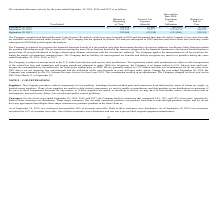From Clearfield's financial document, What is the balance at the beginning of 2019 and 2018 respectively? The document shows two values: $104,858 and 159,154. From the document: "September 30, 2018 159,154 79,377 (133,673) 104,858 September 30, 2019 $ 104,858 $ 10,448 $ (68,292) $ 47,014..." Also, What is the balance at the beginning of 2018 and 2017 respectively? The document shows two values: 159,154 and 322,404. From the document: "September 30, 2017 322,404 (32,154) (131,096) 159,154 September 30, 2017 322,404 (32,154) (131,096) 159,154..." Also, What is the income tax expense of fiscal years 2019 and 2018 respectively? The document shows two values: $10,448 and 79,377. From the document: "September 30, 2018 159,154 79,377 (133,673) 104,858 September 30, 2019 $ 104,858 $ 10,448 $ (68,292) $ 47,014..." Also, can you calculate: What is the percentage change in the end-of-year valuation allowance from 2018 to 2019? To answer this question, I need to perform calculations using the financial data. The calculation is: (47,014-104,858)/104,858, which equals -55.16 (percentage). This is based on the information: "eptember 30, 2019 $ 104,858 $ 10,448 $ (68,292) $ 47,014 September 30, 2019 $ 104,858 $ 10,448 $ (68,292) $ 47,014..." The key data points involved are: 104,858, 47,014. Also, can you calculate: What is the percentage change in the end-of-year valuation allowance from 2017 to 2018? To answer this question, I need to perform calculations using the financial data. The calculation is: (104,858-159,154)/159,154, which equals -34.12 (percentage). This is based on the information: "September 30, 2018 159,154 79,377 (133,673) 104,858 September 30, 2018 159,154 79,377 (133,673) 104,858..." The key data points involved are: 104,858, 159,154. Also, can you calculate: What is the percentage change in the income tax expense from 2018 to 2019? To answer this question, I need to perform calculations using the financial data. The calculation is: (10,448-79,377)/79,377, which equals -86.84 (percentage). This is based on the information: "September 30, 2018 159,154 79,377 (133,673) 104,858 September 30, 2019 $ 104,858 $ 10,448 $ (68,292) $ 47,014..." The key data points involved are: 10,448, 79,377. 